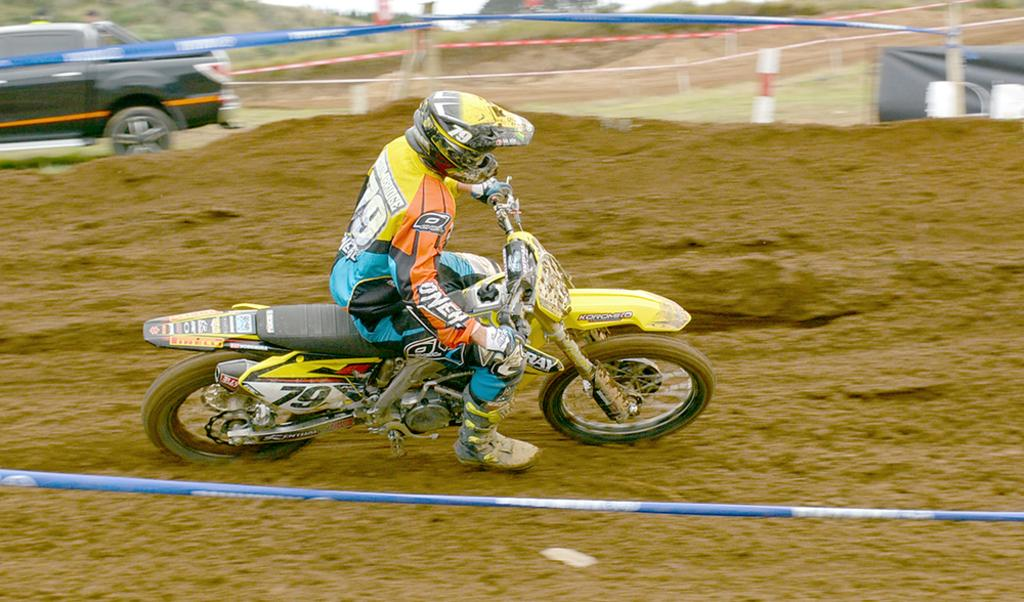What is the person in the image doing? The person is riding a bike in the image. What is the person wearing while riding the bike? The person is wearing a dress and a helmet. What can be seen on the left side of the image? There is a black-colored vehicle on the left side of the image. What type of boot can be seen in the scene? There is no boot present in the image; it features a person riding a bike and a black-colored vehicle. What color is the chalk used to draw on the road in the image? There is no chalk or drawing on the road in the image. 